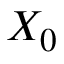Convert formula to latex. <formula><loc_0><loc_0><loc_500><loc_500>X _ { 0 }</formula> 